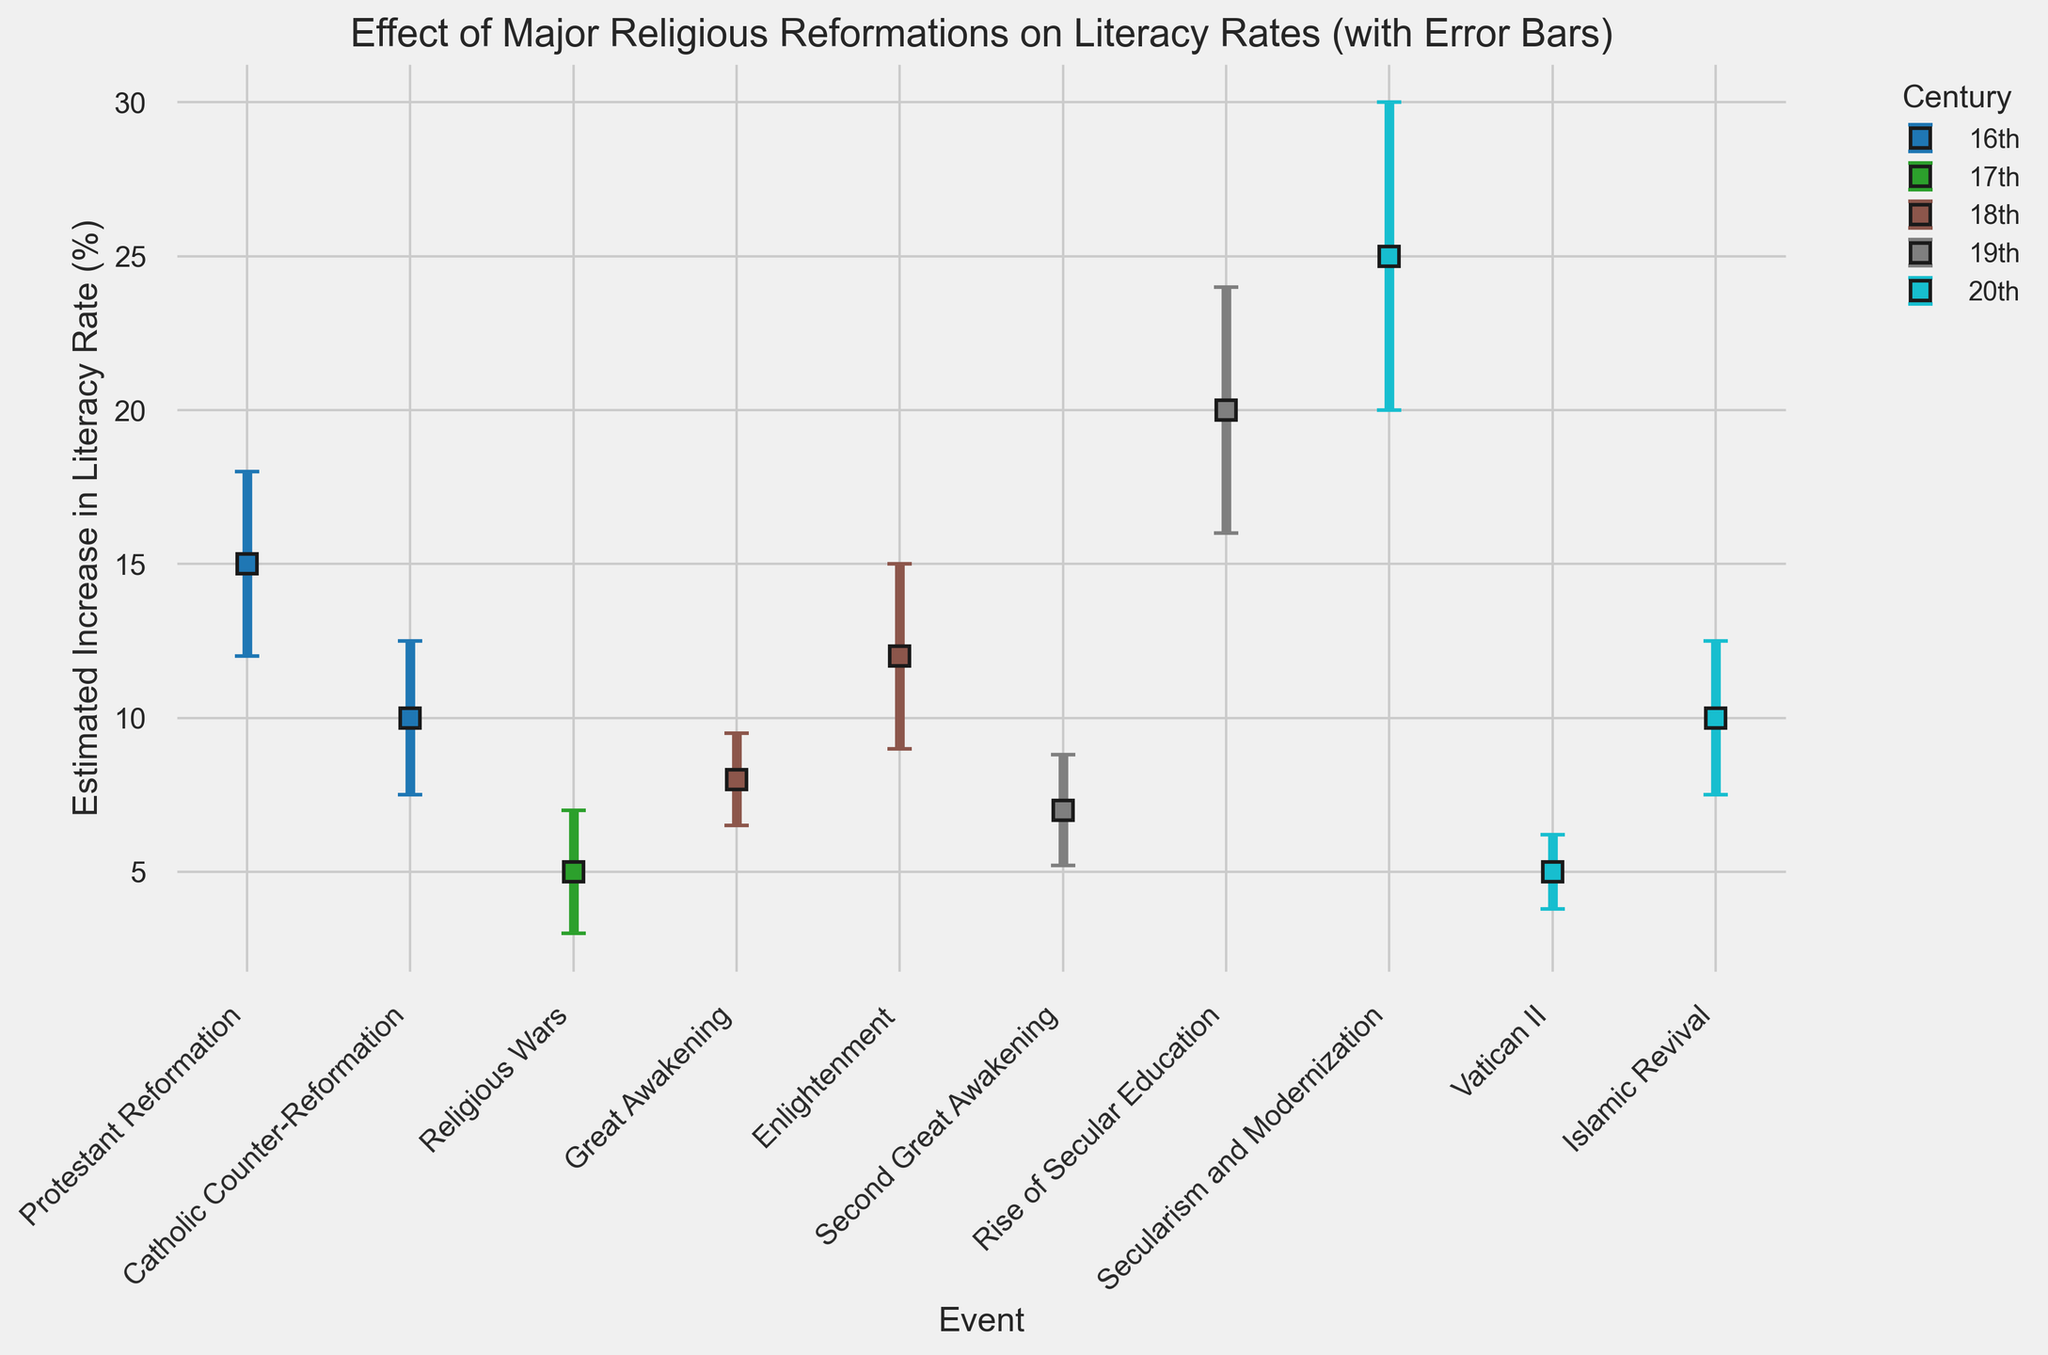What event in the 20th century resulted in the highest estimated increase in literacy rate? To find this, you need to look at the events in the 20th century on the x-axis and compare their corresponding heights. The event "Secularism and Modernization" has the highest bar among the 20th-century events.
Answer: Secularism and Modernization Which event in the 18th century showed the highest estimated increase in literacy rate? Look at the events for the 18th century and compare the heights of their bars. The "Enlightenment" event has a taller bar compared to "Great Awakening".
Answer: Enlightenment What is the estimated increase in literacy rate for the Great Awakening, and what is its standard error? Find the bar labeled "Great Awakening" and observe its height and the vertical error bar. The estimated increase is 8%, and the standard error is 1.5%.
Answer: 8%, 1.5% Compare the estimated increases in literacy rates between the Protestant Reformation and the Second Great Awakening. Which was higher and by how much? Identify the bars for both "Protestant Reformation" and "Second Great Awakening". The Protestant Reformation is 15%, and the Second Great Awakening is 7%. The difference is 15% - 7% = 8%.
Answer: Protestant Reformation, 8% Which events in the figure have a standard error of 2.5%? Check all the error bars and their corresponding standard error values. The events are "Catholic Counter-Reformation" and "Islamic Revival".
Answer: Catholic Counter-Reformation, Islamic Revival What is the overall trend in the estimated increase in literacy rates from the 16th to the 20th century? Observe the average heights of the bars for each century. Starting from the 16th century to the 20th century, there is an increasing trend, culminating in the highest values in the 20th century.
Answer: Increasing trend Which event corresponds to the smallest estimated increase in literacy rate in the 20th century, and what is its value? Look for the shortest bar among the 20th-century events. "Vatican II" has the smallest increase, which is 5%.
Answer: Vatican II, 5% Calculate the mean estimated increase in literacy rate for events in the 19th century. Identify the bars from the 19th century: "Second Great Awakening" (7%) and "Rise of Secular Education" (20%). Calculate the mean as (7% + 20%) / 2 = 13.5%.
Answer: 13.5% Compare the estimated increases in literacy rates between North America in the 18th century and Europe in the 18th century. Compare the heights of "Great Awakening" (North America) and "Enlightenment" (Europe). The "Great Awakening" is 8%, and the "Enlightenment" is 12%.
Answer: Europe, 4% What is the difference between the estimated increases in literacy rates for the events with the highest and lowest values in the entire chart? Identify the highest value, which is "Secularism and Modernization" (25%), and the lowest value, which is "Religious Wars" (5%). The difference is 25% - 5% = 20%.
Answer: 20% 